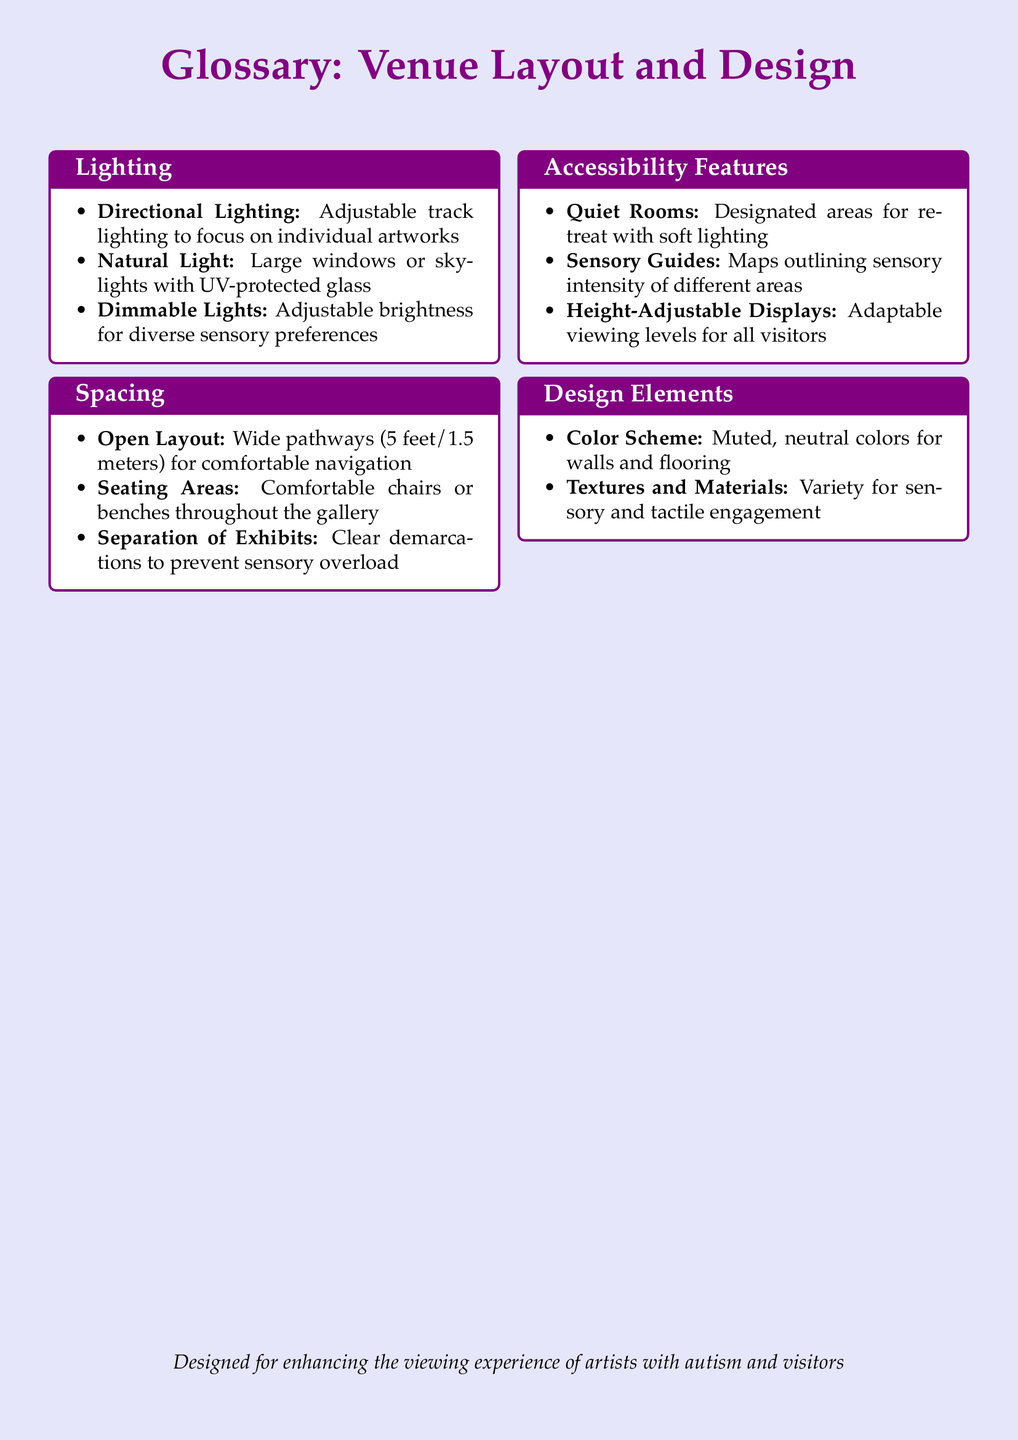What is the height of the pathways? The document specifies that the width of the pathways should be 5 feet or 1.5 meters to ensure comfortable navigation.
Answer: 5 feet What type of lighting is adjustable? The glossary defines directional lighting as adjustable track lighting that can focus on individual artworks, making it a specific type of lighting mentioned.
Answer: Directional Lighting What feature helps visitors retreat during the exhibition? Quiet rooms are design elements intended as designated areas for retreat, equipped with soft lighting for comfort.
Answer: Quiet Rooms What is used to outline sensory intensity in different areas? Sensory guides are mentioned as tools provided to outline the sensory intensity of different areas within the gallery, aiding visitors in their experience.
Answer: Sensory Guides What color scheme is used for walls and flooring? The document states that a muted, neutral color scheme is employed for the gallery's walls and flooring, contributing to a calm viewing experience.
Answer: Muted, neutral colors What is the purpose of seating areas in the gallery? The seating areas are designed to offer comfortable chairs or benches for visitors to rest, enhancing the viewing experience through comfort and accessibility.
Answer: Comfortable chairs or benches What spacing is recommended between exhibits? The glossary mentions clear demarcations to separate exhibits as a design choice, aimed at preventing sensory overload during the exhibition.
Answer: Clear demarcations What material aspect enhances tactile engagement? The document highlights the use of a variety of textures and materials in the gallery as a means to facilitate sensory and tactile engagement with the artwork.
Answer: Textures and Materials 